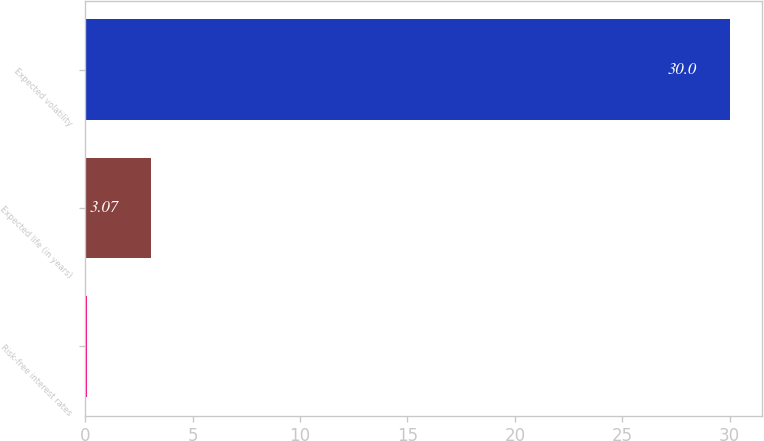Convert chart to OTSL. <chart><loc_0><loc_0><loc_500><loc_500><bar_chart><fcel>Risk-free interest rates<fcel>Expected life (in years)<fcel>Expected volatility<nl><fcel>0.08<fcel>3.07<fcel>30<nl></chart> 